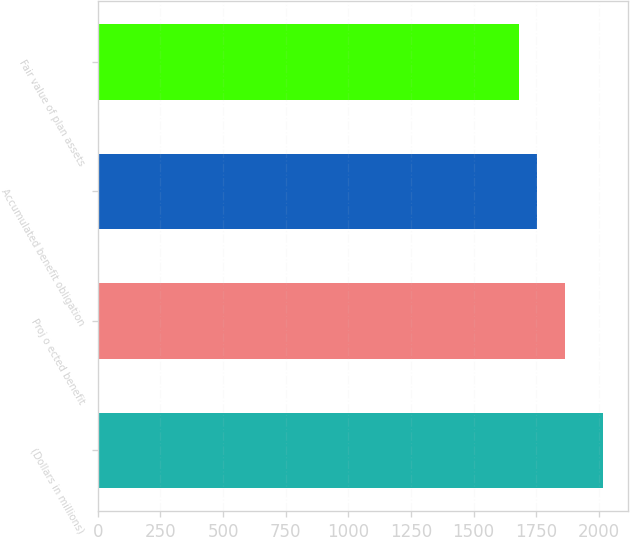Convert chart. <chart><loc_0><loc_0><loc_500><loc_500><bar_chart><fcel>(Dollars in millions)<fcel>Proj o ected benefit<fcel>Accumulated benefit obligation<fcel>Fair value of plan assets<nl><fcel>2016<fcel>1865<fcel>1754<fcel>1680<nl></chart> 